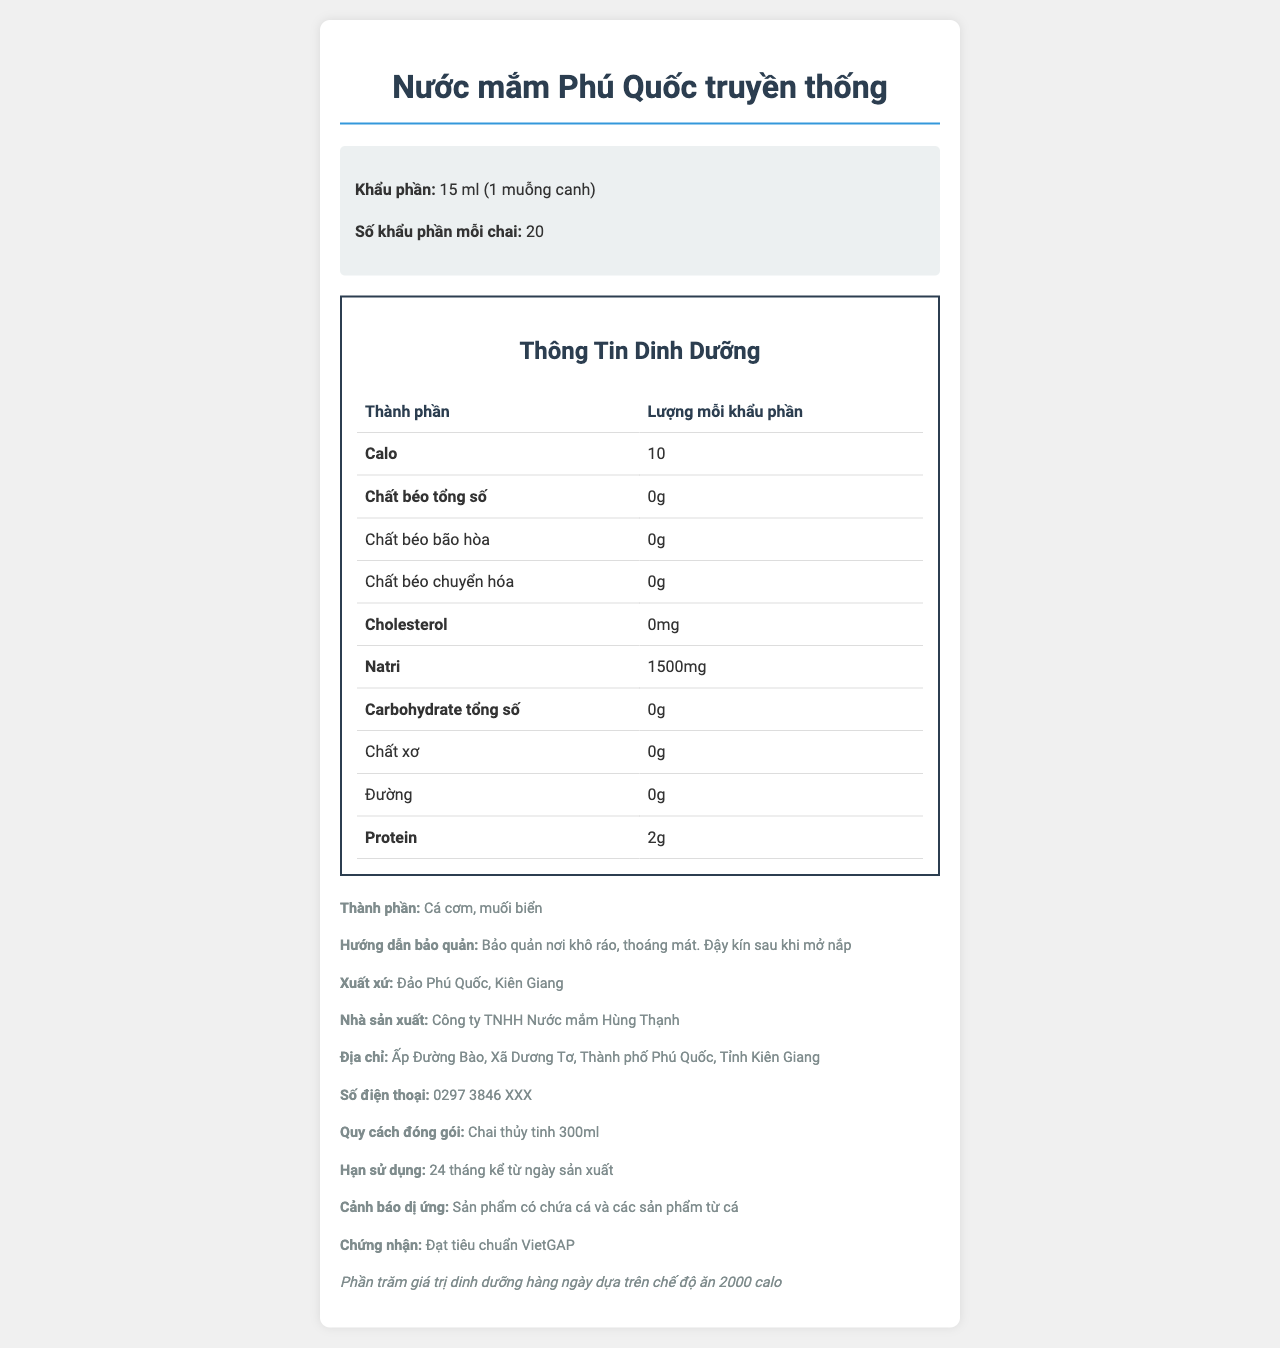what is the tên_sản_phẩm? The name of the product is indicated at the beginning of the document as "Nước mắm Phú Quốc truyền thống".
Answer: Nước mắm Phú Quốc truyền thống how many calo are in one khẩu_phần? The document states that 1 khẩu phần (serving) contains 10 calories.
Answer: 10 what is the amount of protein per serving? According to the nutrition facts table, each serving contains 2g of protein.
Answer: 2g what is the báo cáo dị_ứng mentioned? The allergy warning section indicates that the product contains fish and fish products.
Answer: Sản phẩm có chứa cá và các sản phẩm từ cá how many servings are there in one chai? The document mentions that there are 20 servings per bottle.
Answer: 20 which nutrients have a percentage daily value listed? A. Canxi B. Sắt C. Kali D. All of the above The document lists percentage daily values for canxi (2%), sắt (1%), and kali (0%).
Answer: D how much natri does one serving contain? A. 1000mg B. 1500mg C. 500mg D. 2000mg One serving contains 1500mg of sodium, as indicated in the nutrition facts table.
Answer: B is there any cholesterol in the sản_phẩm? The document specifies that there is 0mg of cholesterol per serving.
Answer: No how long is the hạn_sử_dụng of the product? According to the document, the product has a shelf life of 24 months from the production date.
Answer: 24 months from the production date what is the main message of the nutrition label? The document is detailed and provides necessary information a consumer might want to know about the nutritional value and other specifics of the fish sauce.
Answer: The document provides comprehensive nutritional information about the traditional Phu Quoc fish sauce, including calories, fats, proteins, minerals, ingredients, storage instructions, origin, manufacturer details, packaging, and expiration. what is the email address of the nhà_sản_xuất? The document does not provide an email address for the manufacturer, only a phone number.
Answer: Not enough information 